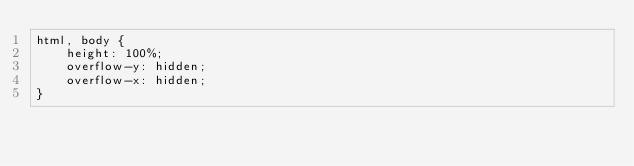<code> <loc_0><loc_0><loc_500><loc_500><_CSS_>html, body {
    height: 100%;
    overflow-y: hidden;
    overflow-x: hidden;
}</code> 